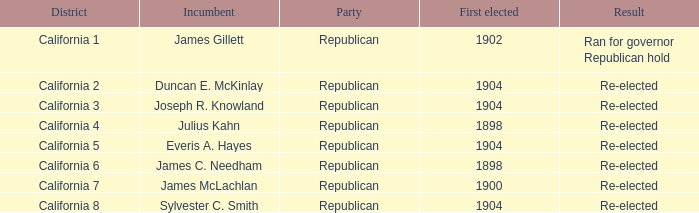In which district is there a re-elected consequence and a first elected in 1898? California 4, California 6. 